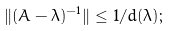<formula> <loc_0><loc_0><loc_500><loc_500>\| ( A - \lambda ) ^ { - 1 } \| \leq 1 / d ( \lambda ) ;</formula> 